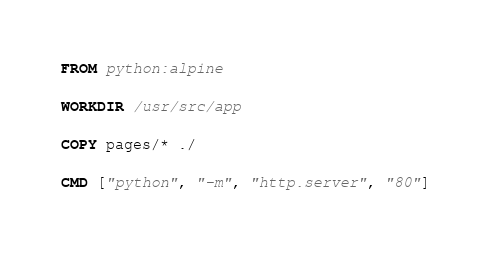Convert code to text. <code><loc_0><loc_0><loc_500><loc_500><_Dockerfile_>FROM python:alpine

WORKDIR /usr/src/app

COPY pages/* ./

CMD ["python", "-m", "http.server", "80"]
</code> 